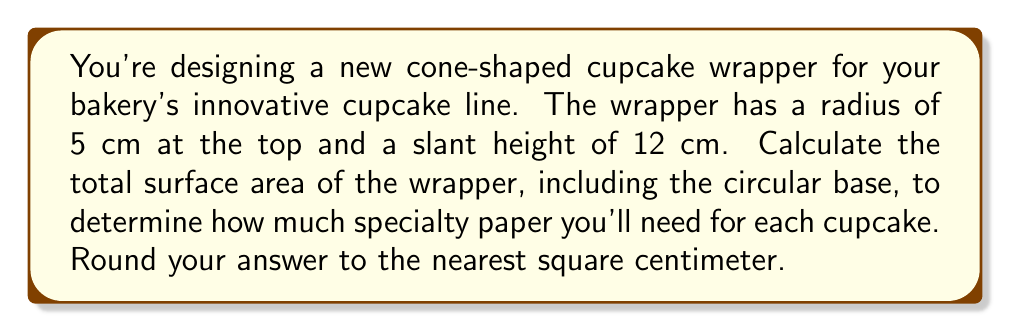Give your solution to this math problem. To solve this problem, we need to calculate the surface area of a cone, which consists of the lateral surface area (the curved part) and the circular base area.

1. Let's define our variables:
   $r$ = radius of the base = 5 cm
   $s$ = slant height = 12 cm

2. The formula for the surface area of a cone is:
   $$ A = \pi r^2 + \pi rs $$
   where $\pi r^2$ is the area of the circular base and $\pi rs$ is the lateral surface area.

3. Let's calculate each part:
   
   Circular base area: $\pi r^2 = \pi (5^2) = 25\pi$ cm²
   
   Lateral surface area: $\pi rs = \pi (5)(12) = 60\pi$ cm²

4. Now, let's add these together:
   $$ A = 25\pi + 60\pi = 85\pi \text{ cm}^2 $$

5. Calculate the numerical value:
   $$ A = 85 \times 3.14159... \approx 266.90 \text{ cm}^2 $$

6. Rounding to the nearest square centimeter:
   $$ A \approx 267 \text{ cm}^2 $$

[asy]
import geometry;

size(200);
pair O=(0,0), A=(5,0), B=(0,12);
draw(O--A--B--cycle);
draw(arc(O,5,0,90),dashed);
label("5 cm",A/2,S);
label("12 cm",(B+A)/2,NE);
label("r",A/2,N);
label("s",B/2,NW);
[/asy]
Answer: $267 \text{ cm}^2$ 